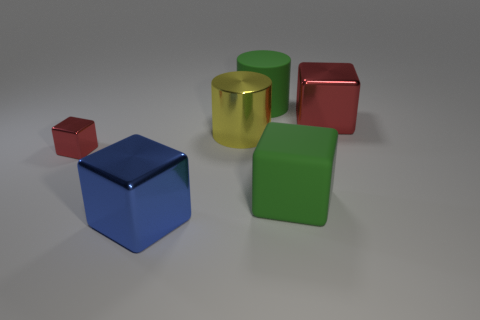What color is the rubber cube?
Keep it short and to the point. Green. What number of cylinders are the same color as the big rubber cube?
Your answer should be compact. 1. What material is the green object that is the same size as the green block?
Offer a very short reply. Rubber. There is a cube behind the small cube; is there a metal object that is in front of it?
Your answer should be compact. Yes. What number of other objects are there of the same color as the small metal object?
Keep it short and to the point. 1. The yellow metal object has what size?
Your answer should be compact. Large. Are any small purple shiny cubes visible?
Offer a very short reply. No. Are there more large green rubber objects that are in front of the yellow metallic object than large green rubber cylinders that are left of the blue metallic block?
Provide a succinct answer. Yes. What is the block that is behind the big green block and on the right side of the big matte cylinder made of?
Provide a succinct answer. Metal. Is the shape of the large blue metal thing the same as the tiny metal thing?
Your answer should be very brief. Yes. 